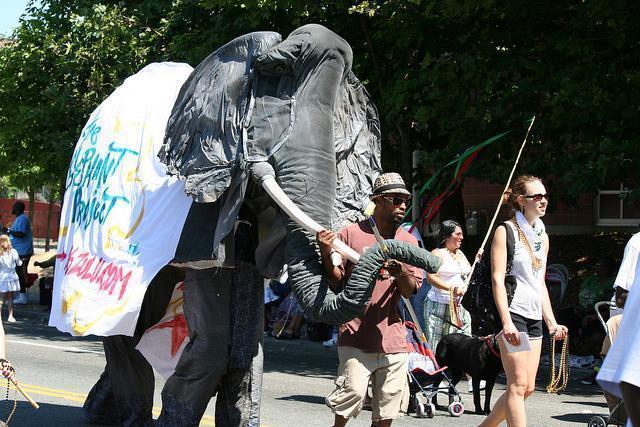What is the ancestral animal of the animal represented here?
Select the correct answer and articulate reasoning with the following format: 'Answer: answer
Rationale: rationale.'
Options: Woolly mammoth, lion, asian elephant, tiger. Answer: woolly mammoth.
Rationale: The animal is a wooly mammoth. 